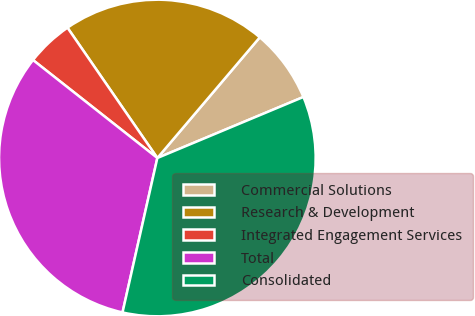Convert chart to OTSL. <chart><loc_0><loc_0><loc_500><loc_500><pie_chart><fcel>Commercial Solutions<fcel>Research & Development<fcel>Integrated Engagement Services<fcel>Total<fcel>Consolidated<nl><fcel>7.5%<fcel>20.81%<fcel>4.77%<fcel>32.09%<fcel>34.83%<nl></chart> 